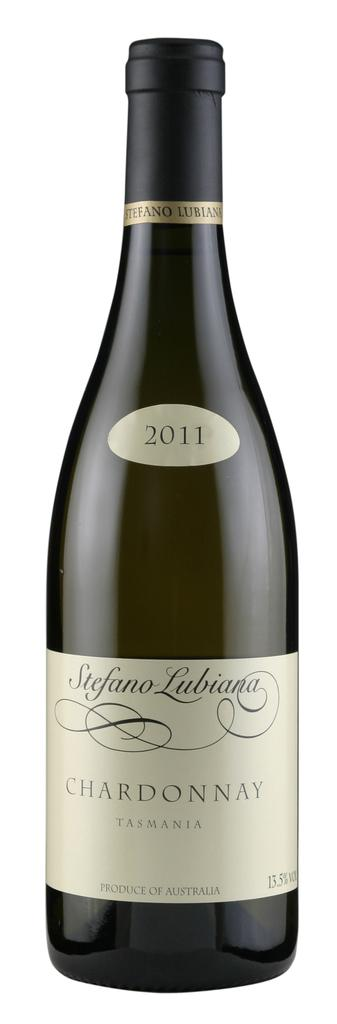<image>
Summarize the visual content of the image. a bottle of stefano lubiana chardonnay from 2011 